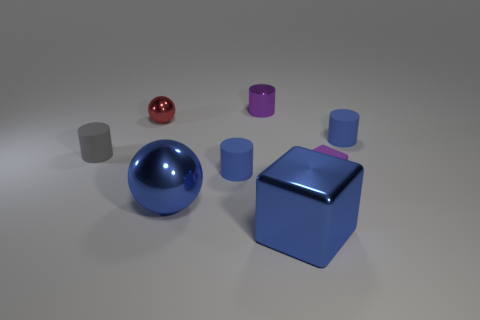Subtract all purple cylinders. How many cylinders are left? 3 Subtract all cyan cylinders. Subtract all brown blocks. How many cylinders are left? 4 Add 1 big blue metallic things. How many objects exist? 9 Subtract all blocks. How many objects are left? 6 Subtract 0 green blocks. How many objects are left? 8 Subtract all blue cubes. Subtract all matte cubes. How many objects are left? 6 Add 5 red shiny objects. How many red shiny objects are left? 6 Add 5 gray matte things. How many gray matte things exist? 6 